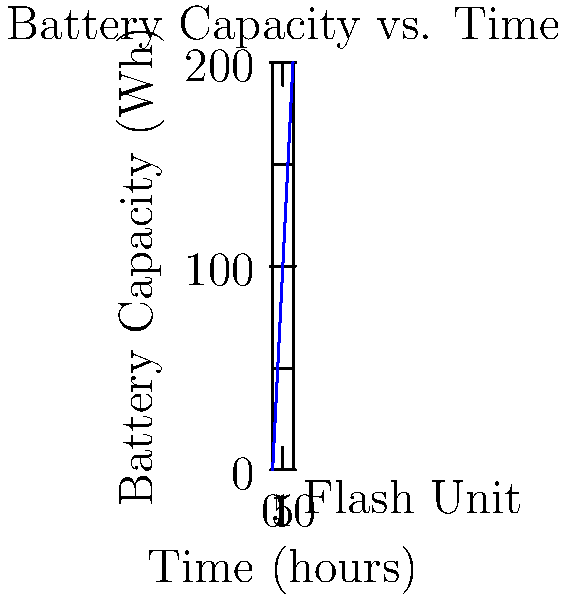As a photographer working on a retiree's fashion shoot, you need to calculate the required battery capacity for a portable flash unit. The flash unit has a power output of 60 watts and you want it to be able to produce 500 flashes. Each flash lasts for 1/1000 of a second. What is the minimum battery capacity required in watt-hours (Wh)? To calculate the required battery capacity, we need to follow these steps:

1. Calculate the energy consumed per flash:
   Energy per flash = Power × Time
   $E = P \times t = 60 \text{ W} \times \frac{1}{1000} \text{ s} = 0.06 \text{ J}$

2. Calculate the total energy required for 500 flashes:
   Total energy = Energy per flash × Number of flashes
   $E_{\text{total}} = 0.06 \text{ J} \times 500 = 30 \text{ J}$

3. Convert joules to watt-hours:
   1 Wh = 3600 J (since 1 hour = 3600 seconds)
   $\text{Battery capacity (Wh)} = \frac{30 \text{ J}}{3600 \text{ J/Wh}} = 0.00833 \text{ Wh}$

4. Round up to the nearest practical value:
   The calculated capacity is very small, so we should round up to a practical value, such as 0.01 Wh or 10 mWh.
Answer: 0.01 Wh (or 10 mWh) 